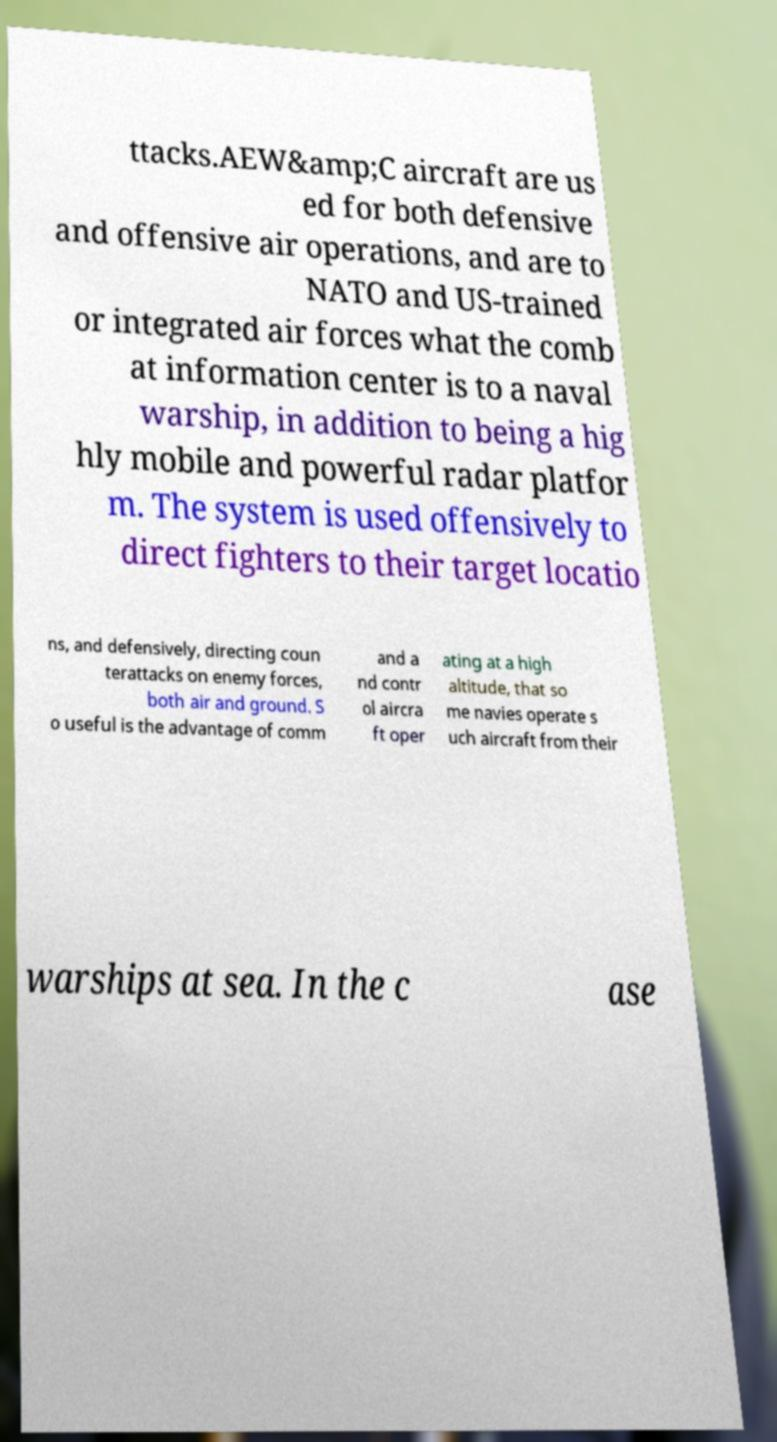Can you accurately transcribe the text from the provided image for me? ttacks.AEW&amp;C aircraft are us ed for both defensive and offensive air operations, and are to NATO and US-trained or integrated air forces what the comb at information center is to a naval warship, in addition to being a hig hly mobile and powerful radar platfor m. The system is used offensively to direct fighters to their target locatio ns, and defensively, directing coun terattacks on enemy forces, both air and ground. S o useful is the advantage of comm and a nd contr ol aircra ft oper ating at a high altitude, that so me navies operate s uch aircraft from their warships at sea. In the c ase 